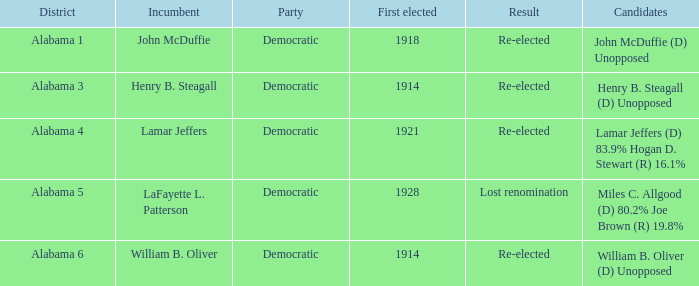How many in lost renomination results were elected first? 1928.0. 